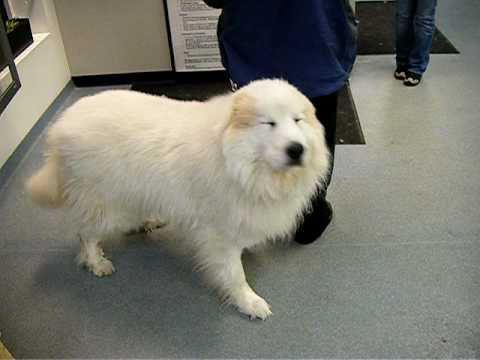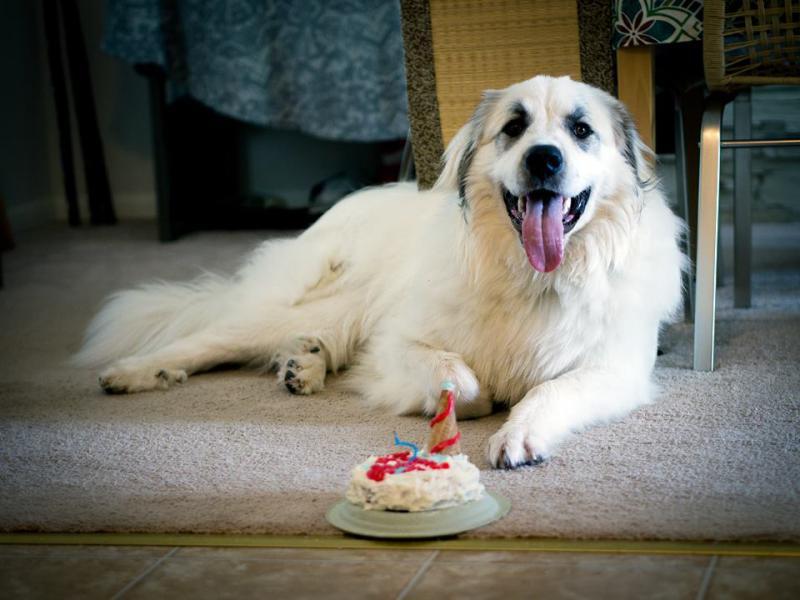The first image is the image on the left, the second image is the image on the right. Evaluate the accuracy of this statement regarding the images: "An image contains a large white dog laying down next to framed certificates.". Is it true? Answer yes or no. No. The first image is the image on the left, the second image is the image on the right. Considering the images on both sides, is "In one of the images, a white dog is laying down behind at least three framed documents." valid? Answer yes or no. No. 